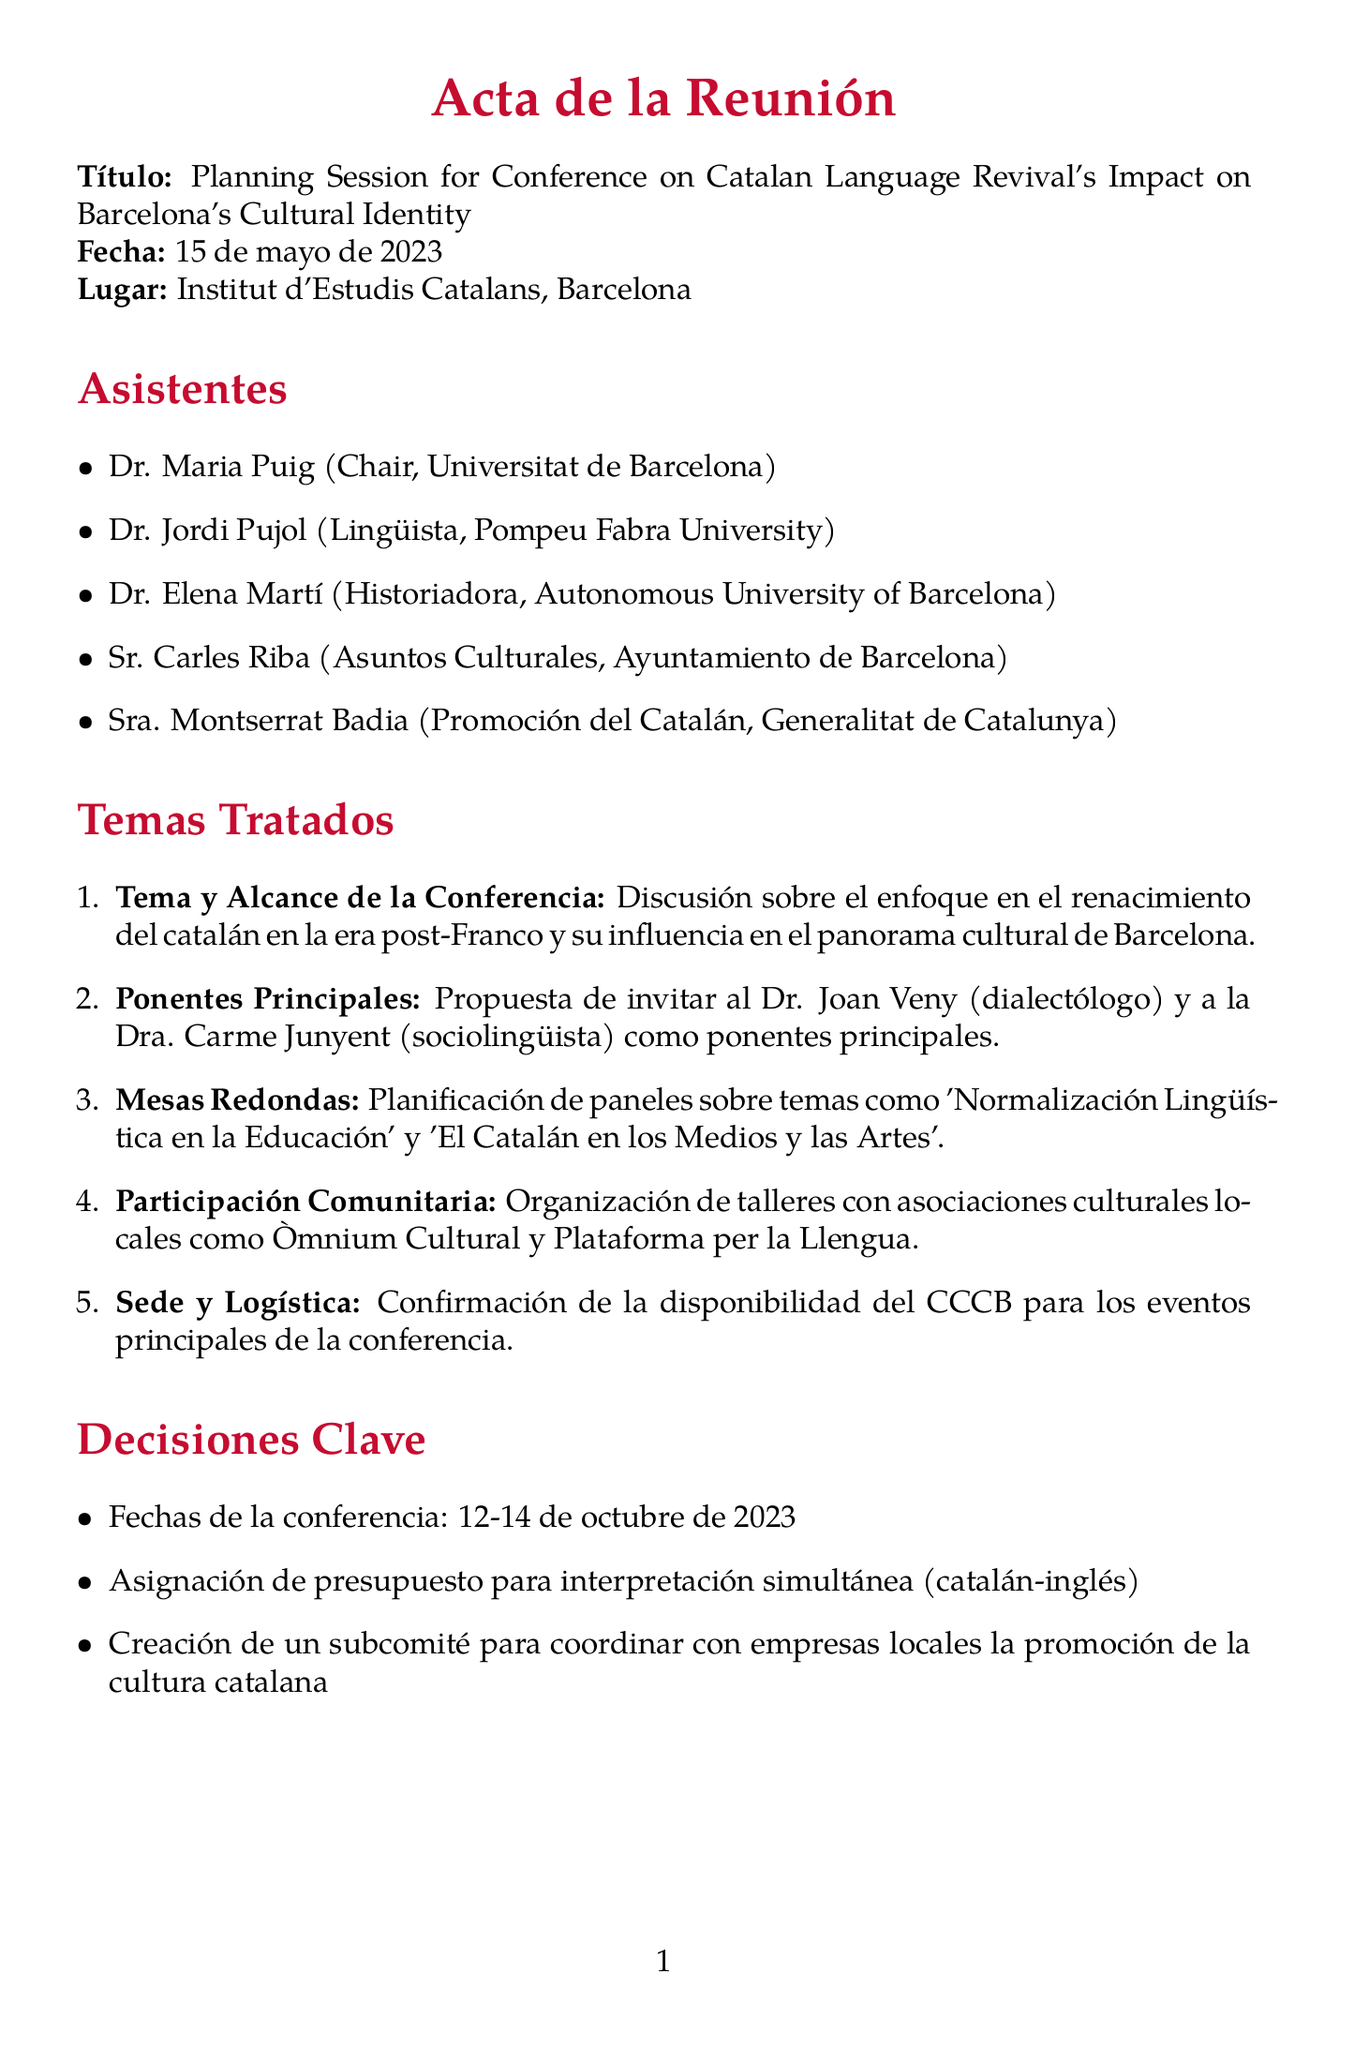What is the title of the meeting? The title of the meeting is provided in the document under "Título."
Answer: Planning Session for Conference on Catalan Language Revival's Impact on Barcelona's Cultural Identity When is the conference scheduled? The document includes specific dates for the conference listed under "Decisiones Clave."
Answer: October 12-14, 2023 Who is responsible for drafting the call for papers? The action item section specifies the person responsible for this task.
Answer: Dr. Elena Martí What two topics are suggested for panel discussions? The details of the panel discussions are listed in the agenda items.
Answer: Linguistic Normalization in Education, Catalan in Media and Arts Where will the main conference events take place? The logistics section mentions the venue for the conference.
Answer: CCCB (Centre de Cultura Contemporània de Barcelona) What language will be used for interpretation at the conference? The key decisions mention the language allocation in the interpretation budget.
Answer: Catalan-English Who are the proposed keynote speakers? The agenda items list the names of the proposed speakers.
Answer: Dr. Joan Veny, Dr. Carme Junyent What is one of the cultural associations mentioned for community involvement? The agenda details mention specific local associations for workshops.
Answer: Òmnium Cultural 